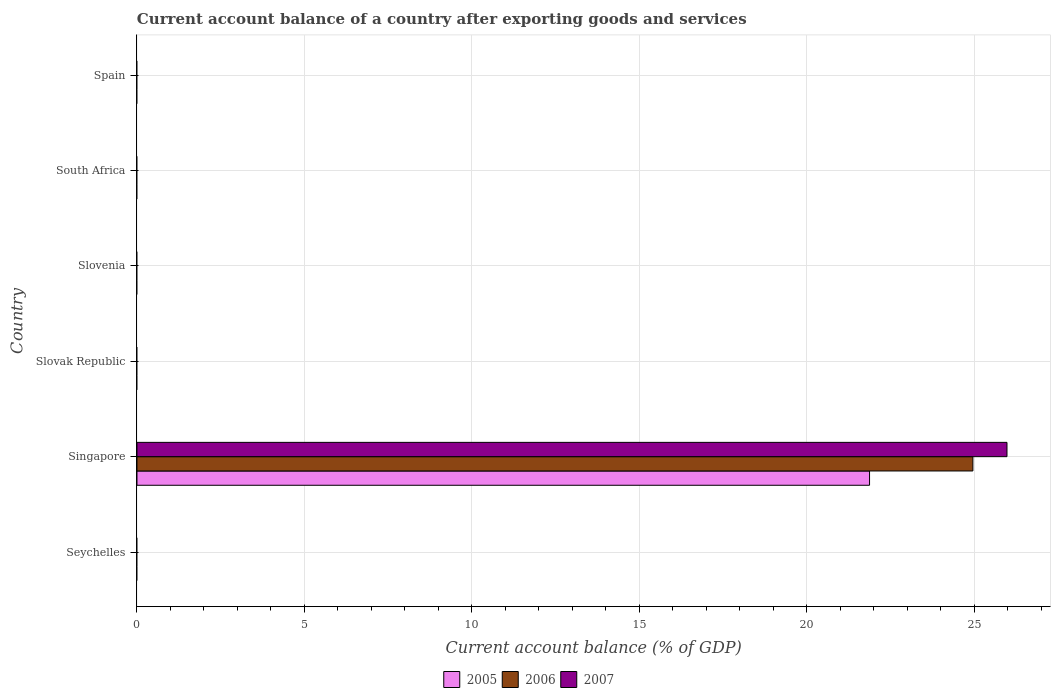How many different coloured bars are there?
Offer a terse response. 3. How many bars are there on the 1st tick from the top?
Your answer should be compact. 0. What is the label of the 2nd group of bars from the top?
Your answer should be very brief. South Africa. In how many cases, is the number of bars for a given country not equal to the number of legend labels?
Your response must be concise. 5. What is the account balance in 2006 in South Africa?
Offer a very short reply. 0. Across all countries, what is the maximum account balance in 2006?
Give a very brief answer. 24.96. In which country was the account balance in 2007 maximum?
Keep it short and to the point. Singapore. What is the total account balance in 2006 in the graph?
Provide a succinct answer. 24.96. What is the average account balance in 2006 per country?
Make the answer very short. 4.16. What is the difference between the account balance in 2006 and account balance in 2005 in Singapore?
Make the answer very short. 3.09. In how many countries, is the account balance in 2006 greater than 25 %?
Give a very brief answer. 0. What is the difference between the highest and the lowest account balance in 2006?
Make the answer very short. 24.96. In how many countries, is the account balance in 2006 greater than the average account balance in 2006 taken over all countries?
Offer a very short reply. 1. How many bars are there?
Give a very brief answer. 3. How many countries are there in the graph?
Your answer should be compact. 6. Does the graph contain grids?
Give a very brief answer. Yes. Where does the legend appear in the graph?
Provide a short and direct response. Bottom center. How many legend labels are there?
Make the answer very short. 3. How are the legend labels stacked?
Your answer should be compact. Horizontal. What is the title of the graph?
Make the answer very short. Current account balance of a country after exporting goods and services. Does "1993" appear as one of the legend labels in the graph?
Your answer should be very brief. No. What is the label or title of the X-axis?
Provide a succinct answer. Current account balance (% of GDP). What is the label or title of the Y-axis?
Provide a short and direct response. Country. What is the Current account balance (% of GDP) in 2005 in Seychelles?
Your answer should be compact. 0. What is the Current account balance (% of GDP) of 2005 in Singapore?
Ensure brevity in your answer.  21.87. What is the Current account balance (% of GDP) in 2006 in Singapore?
Ensure brevity in your answer.  24.96. What is the Current account balance (% of GDP) in 2007 in Singapore?
Your answer should be very brief. 25.97. What is the Current account balance (% of GDP) in 2005 in Slovak Republic?
Give a very brief answer. 0. What is the Current account balance (% of GDP) in 2005 in Spain?
Offer a very short reply. 0. What is the Current account balance (% of GDP) in 2006 in Spain?
Offer a very short reply. 0. What is the Current account balance (% of GDP) in 2007 in Spain?
Keep it short and to the point. 0. Across all countries, what is the maximum Current account balance (% of GDP) in 2005?
Offer a very short reply. 21.87. Across all countries, what is the maximum Current account balance (% of GDP) in 2006?
Provide a short and direct response. 24.96. Across all countries, what is the maximum Current account balance (% of GDP) in 2007?
Keep it short and to the point. 25.97. Across all countries, what is the minimum Current account balance (% of GDP) in 2006?
Keep it short and to the point. 0. Across all countries, what is the minimum Current account balance (% of GDP) in 2007?
Provide a succinct answer. 0. What is the total Current account balance (% of GDP) of 2005 in the graph?
Provide a succinct answer. 21.87. What is the total Current account balance (% of GDP) in 2006 in the graph?
Ensure brevity in your answer.  24.96. What is the total Current account balance (% of GDP) of 2007 in the graph?
Give a very brief answer. 25.97. What is the average Current account balance (% of GDP) in 2005 per country?
Ensure brevity in your answer.  3.65. What is the average Current account balance (% of GDP) in 2006 per country?
Keep it short and to the point. 4.16. What is the average Current account balance (% of GDP) in 2007 per country?
Offer a very short reply. 4.33. What is the difference between the Current account balance (% of GDP) of 2005 and Current account balance (% of GDP) of 2006 in Singapore?
Provide a short and direct response. -3.08. What is the difference between the Current account balance (% of GDP) of 2005 and Current account balance (% of GDP) of 2007 in Singapore?
Your answer should be compact. -4.1. What is the difference between the Current account balance (% of GDP) of 2006 and Current account balance (% of GDP) of 2007 in Singapore?
Your answer should be compact. -1.02. What is the difference between the highest and the lowest Current account balance (% of GDP) in 2005?
Provide a short and direct response. 21.87. What is the difference between the highest and the lowest Current account balance (% of GDP) of 2006?
Your answer should be compact. 24.96. What is the difference between the highest and the lowest Current account balance (% of GDP) in 2007?
Make the answer very short. 25.97. 